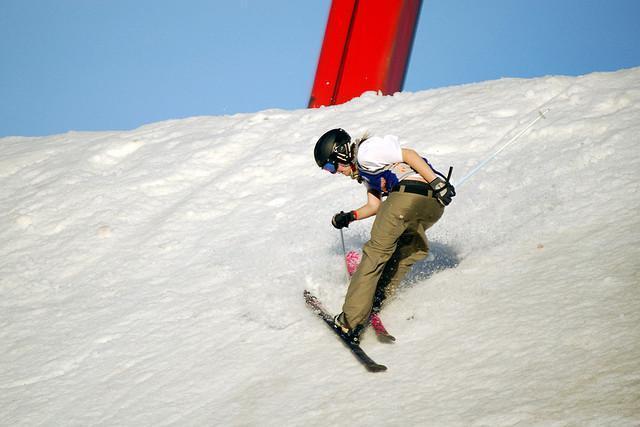How many bananas is the person holding?
Give a very brief answer. 0. 